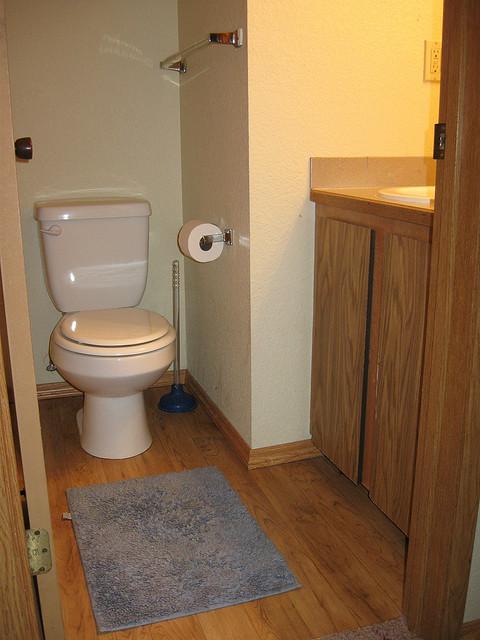What color is the floor mat under the toilet?
Write a very short answer. Blue. How many toilets are in the bathroom?
Be succinct. 1. Is the floor covered in marble?
Write a very short answer. No. The plunger is white?
Quick response, please. No. Can someone get a device to unclog the toilet?
Write a very short answer. Yes. Is there tile on floors?
Be succinct. No. What color is the plunger?
Write a very short answer. Blue. 